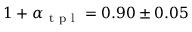<formula> <loc_0><loc_0><loc_500><loc_500>1 + \alpha _ { t p l } = 0 . 9 0 \pm 0 . 0 5</formula> 